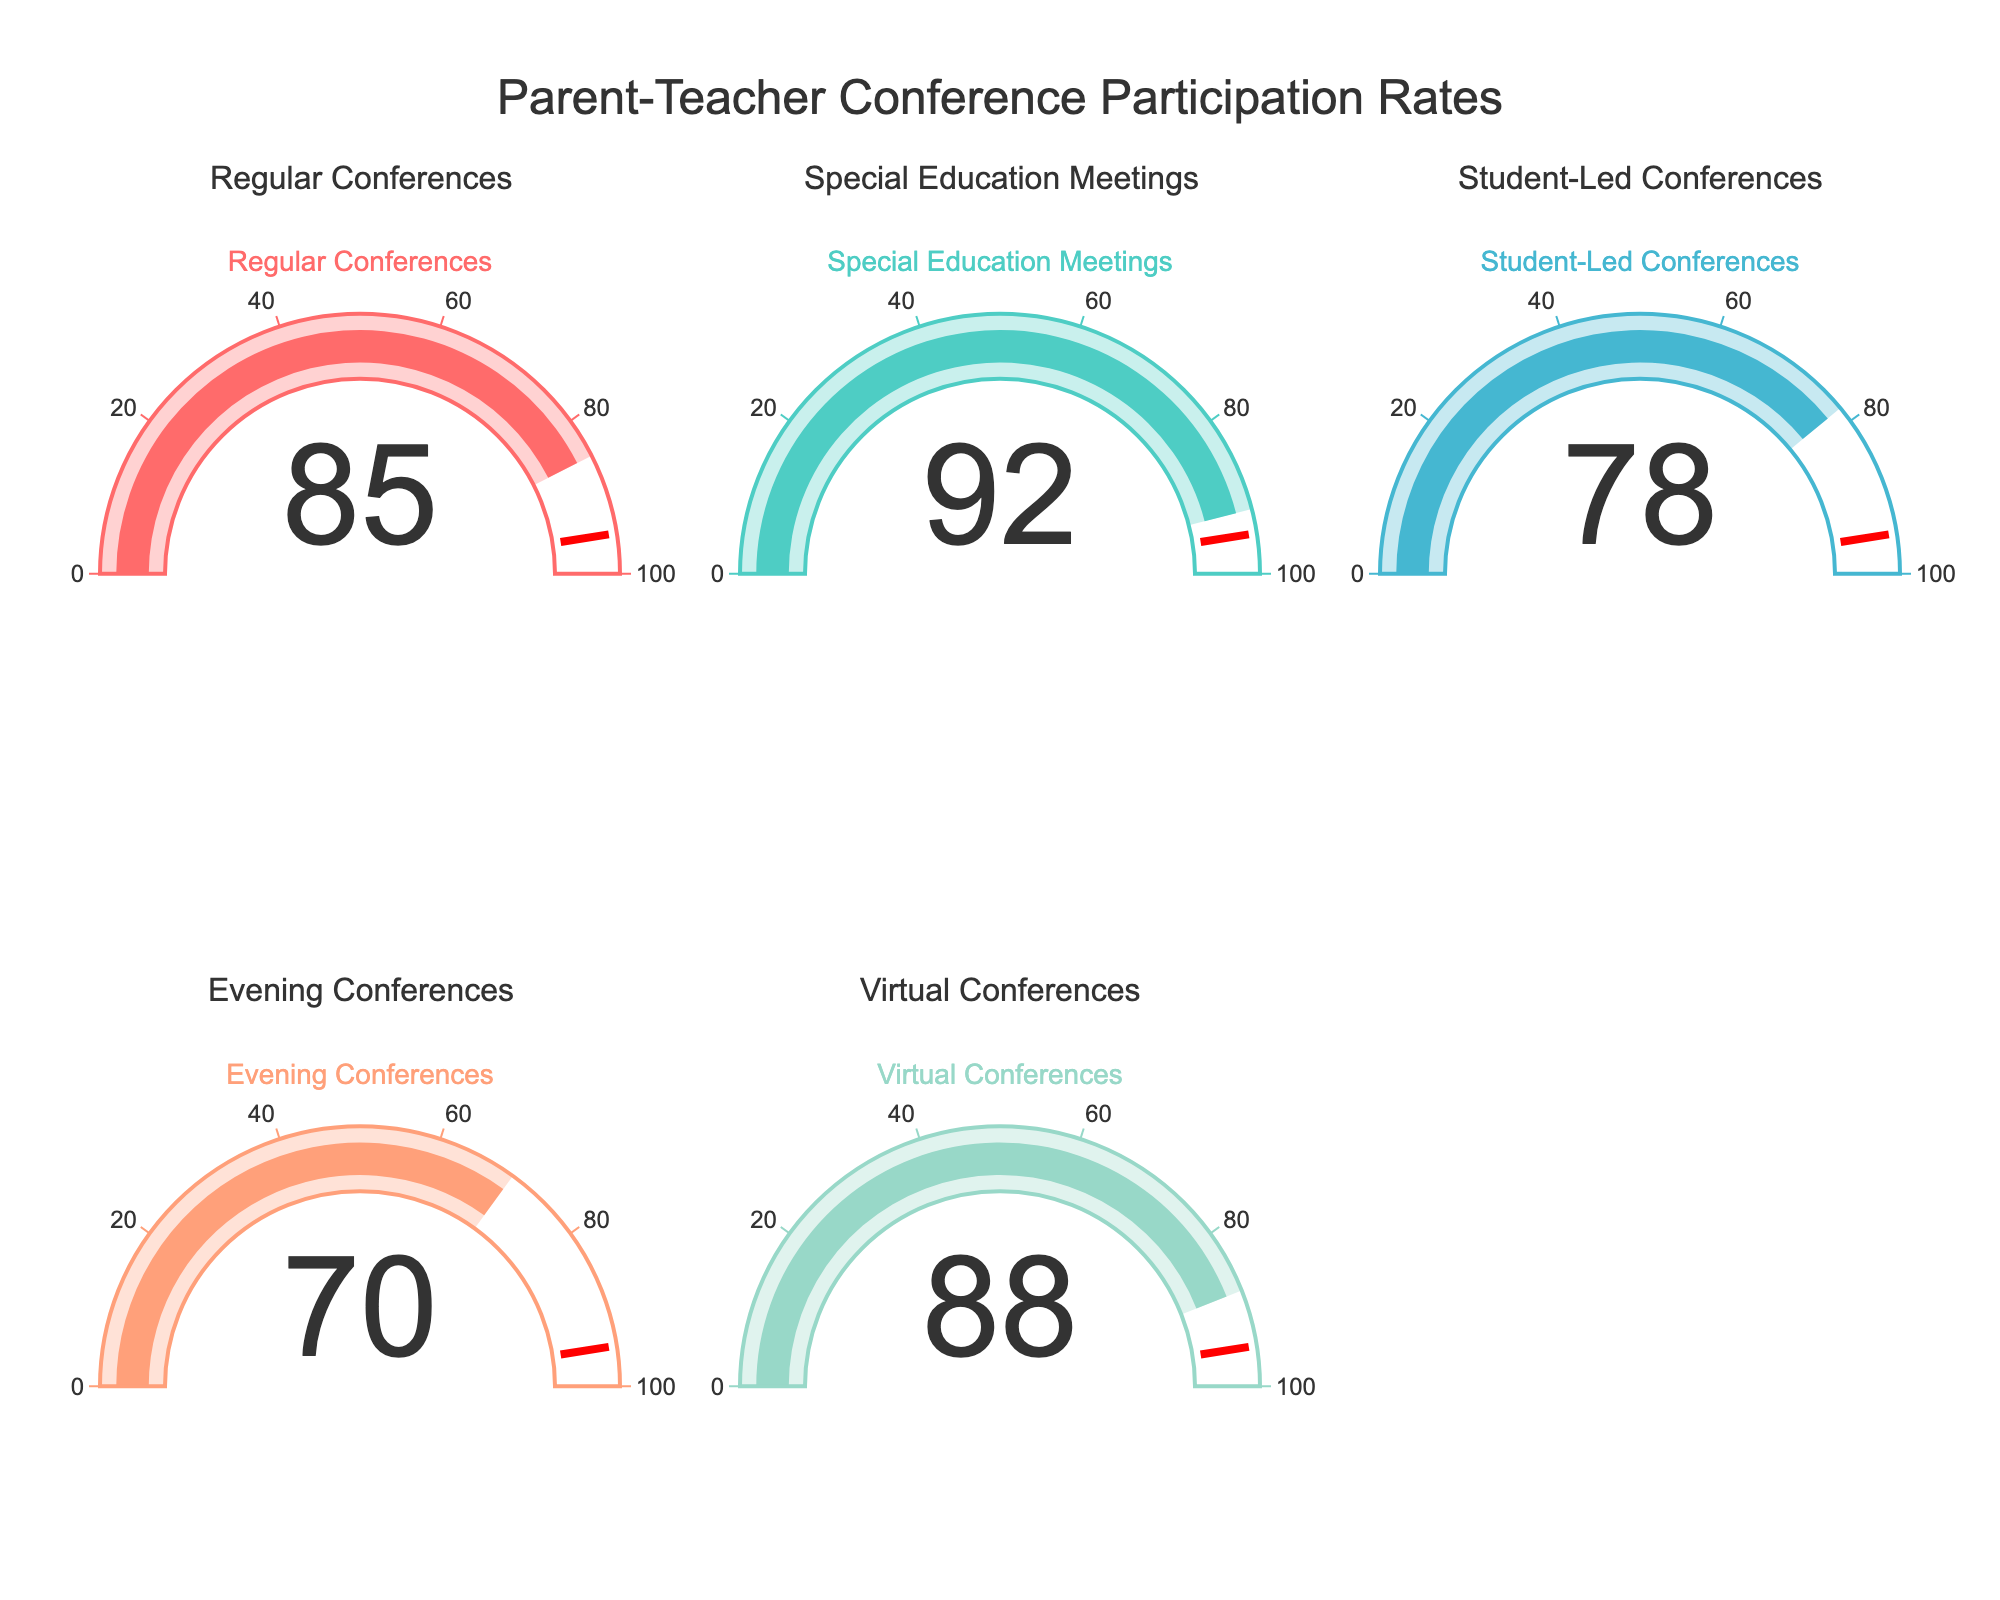What is the participation rate for Virtual Conferences? The gauge chart labeled "Virtual Conferences" indicates a participation rate.
Answer: 88 Which conference type has the highest participation rate? By visually comparing the values shown on each gauge chart, the gauge chart for Special Education Meetings has the highest value.
Answer: Special Education Meetings How much higher is the participation rate for Regular Conferences compared to Student-Led Conferences? Subtract the participation rate of Student-Led Conferences (78) from the participation rate of Regular Conferences (85) to find the difference: 85 - 78 = 7.
Answer: 7 What is the average participation rate across all conference types? Sum the participation rates (85 + 92 + 78 + 70 + 88) = 413 and divide by the number of conference types (5) to get the average: 413 / 5 = 82.6.
Answer: 82.6 Is the participation rate for Evening Conferences above the threshold set on the gauge? The threshold line for all gauges is set at 95. The participation rate for Evening Conferences is 70, which is below the threshold of 95.
Answer: No Among Regular Conferences and Virtual Conferences, which one has a higher participation rate and by how much? Virtual Conferences have a participation rate of 88, whereas Regular Conferences have 85. Subtract 85 from 88 to find the difference: 88 - 85 = 3.
Answer: Virtual Conferences by 3 What is the total number of conference types displayed in the figure? Count the number of gauge charts displayed in the figure; there are five different conference types.
Answer: 5 Which conference type has a participation rate closest to the overall average? The average participation rate is 82.6. By comparing each rate to this average:
- Regular Conferences: 85 (closest so far)
- Special Education Meetings: 92 (further from average)
- Student-Led Conferences: 78 (closest so far)
- Evening Conferences: 70 (further from average)
- Virtual Conferences: 88 (closest so far)
The closest value to 82.6 is 85.
Answer: Regular Conferences 